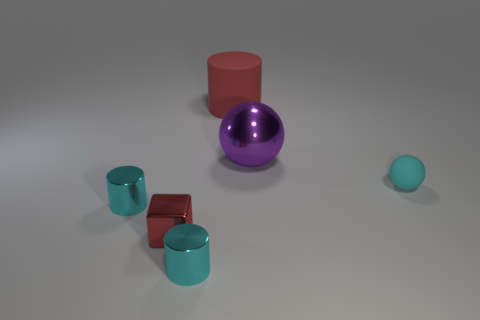What number of cyan things are right of the purple metal sphere and on the left side of the large purple ball?
Your response must be concise. 0. The tiny metallic block has what color?
Provide a short and direct response. Red. What material is the other large object that is the same shape as the cyan rubber thing?
Provide a succinct answer. Metal. Does the cube have the same color as the large rubber thing?
Keep it short and to the point. Yes. There is a red thing that is behind the matte object right of the purple thing; what is its shape?
Provide a short and direct response. Cylinder. There is a purple object that is the same material as the red block; what is its shape?
Your response must be concise. Sphere. What number of other things are there of the same shape as the tiny red object?
Offer a very short reply. 0. There is a cyan object that is right of the red cylinder; does it have the same size as the big red rubber cylinder?
Offer a very short reply. No. Is the number of objects behind the metal sphere greater than the number of yellow rubber spheres?
Provide a short and direct response. Yes. There is a small cylinder behind the tiny red metallic thing; how many red shiny blocks are behind it?
Your response must be concise. 0. 